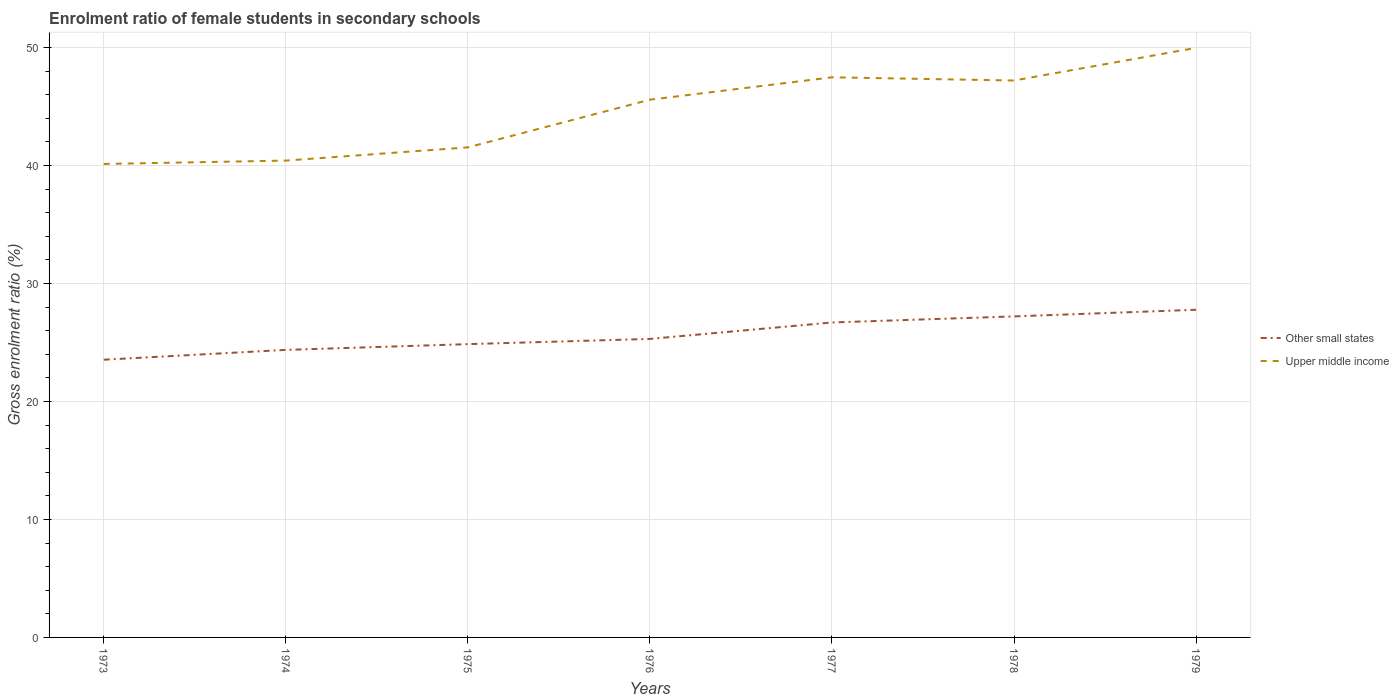Does the line corresponding to Other small states intersect with the line corresponding to Upper middle income?
Keep it short and to the point. No. Across all years, what is the maximum enrolment ratio of female students in secondary schools in Upper middle income?
Your response must be concise. 40.13. What is the total enrolment ratio of female students in secondary schools in Other small states in the graph?
Offer a very short reply. -0.49. What is the difference between the highest and the second highest enrolment ratio of female students in secondary schools in Other small states?
Ensure brevity in your answer.  4.23. Is the enrolment ratio of female students in secondary schools in Other small states strictly greater than the enrolment ratio of female students in secondary schools in Upper middle income over the years?
Keep it short and to the point. Yes. What is the difference between two consecutive major ticks on the Y-axis?
Your response must be concise. 10. Does the graph contain any zero values?
Provide a succinct answer. No. How many legend labels are there?
Your answer should be compact. 2. What is the title of the graph?
Ensure brevity in your answer.  Enrolment ratio of female students in secondary schools. Does "West Bank and Gaza" appear as one of the legend labels in the graph?
Make the answer very short. No. What is the Gross enrolment ratio (%) of Other small states in 1973?
Provide a short and direct response. 23.54. What is the Gross enrolment ratio (%) in Upper middle income in 1973?
Your answer should be very brief. 40.13. What is the Gross enrolment ratio (%) in Other small states in 1974?
Your response must be concise. 24.37. What is the Gross enrolment ratio (%) in Upper middle income in 1974?
Ensure brevity in your answer.  40.42. What is the Gross enrolment ratio (%) of Other small states in 1975?
Make the answer very short. 24.86. What is the Gross enrolment ratio (%) in Upper middle income in 1975?
Offer a terse response. 41.54. What is the Gross enrolment ratio (%) of Other small states in 1976?
Your answer should be very brief. 25.3. What is the Gross enrolment ratio (%) in Upper middle income in 1976?
Your response must be concise. 45.58. What is the Gross enrolment ratio (%) of Other small states in 1977?
Make the answer very short. 26.7. What is the Gross enrolment ratio (%) in Upper middle income in 1977?
Your answer should be very brief. 47.48. What is the Gross enrolment ratio (%) of Other small states in 1978?
Your answer should be compact. 27.21. What is the Gross enrolment ratio (%) of Upper middle income in 1978?
Make the answer very short. 47.21. What is the Gross enrolment ratio (%) of Other small states in 1979?
Give a very brief answer. 27.77. What is the Gross enrolment ratio (%) in Upper middle income in 1979?
Your answer should be compact. 49.98. Across all years, what is the maximum Gross enrolment ratio (%) in Other small states?
Keep it short and to the point. 27.77. Across all years, what is the maximum Gross enrolment ratio (%) in Upper middle income?
Make the answer very short. 49.98. Across all years, what is the minimum Gross enrolment ratio (%) in Other small states?
Your response must be concise. 23.54. Across all years, what is the minimum Gross enrolment ratio (%) in Upper middle income?
Your answer should be very brief. 40.13. What is the total Gross enrolment ratio (%) in Other small states in the graph?
Keep it short and to the point. 179.76. What is the total Gross enrolment ratio (%) in Upper middle income in the graph?
Your answer should be compact. 312.34. What is the difference between the Gross enrolment ratio (%) of Other small states in 1973 and that in 1974?
Make the answer very short. -0.83. What is the difference between the Gross enrolment ratio (%) in Upper middle income in 1973 and that in 1974?
Ensure brevity in your answer.  -0.29. What is the difference between the Gross enrolment ratio (%) of Other small states in 1973 and that in 1975?
Offer a very short reply. -1.32. What is the difference between the Gross enrolment ratio (%) in Upper middle income in 1973 and that in 1975?
Give a very brief answer. -1.41. What is the difference between the Gross enrolment ratio (%) in Other small states in 1973 and that in 1976?
Your answer should be compact. -1.76. What is the difference between the Gross enrolment ratio (%) in Upper middle income in 1973 and that in 1976?
Offer a terse response. -5.45. What is the difference between the Gross enrolment ratio (%) in Other small states in 1973 and that in 1977?
Keep it short and to the point. -3.16. What is the difference between the Gross enrolment ratio (%) of Upper middle income in 1973 and that in 1977?
Offer a terse response. -7.34. What is the difference between the Gross enrolment ratio (%) in Other small states in 1973 and that in 1978?
Keep it short and to the point. -3.67. What is the difference between the Gross enrolment ratio (%) of Upper middle income in 1973 and that in 1978?
Ensure brevity in your answer.  -7.07. What is the difference between the Gross enrolment ratio (%) of Other small states in 1973 and that in 1979?
Offer a terse response. -4.23. What is the difference between the Gross enrolment ratio (%) in Upper middle income in 1973 and that in 1979?
Your answer should be compact. -9.84. What is the difference between the Gross enrolment ratio (%) in Other small states in 1974 and that in 1975?
Provide a succinct answer. -0.49. What is the difference between the Gross enrolment ratio (%) in Upper middle income in 1974 and that in 1975?
Your response must be concise. -1.12. What is the difference between the Gross enrolment ratio (%) in Other small states in 1974 and that in 1976?
Ensure brevity in your answer.  -0.93. What is the difference between the Gross enrolment ratio (%) of Upper middle income in 1974 and that in 1976?
Make the answer very short. -5.16. What is the difference between the Gross enrolment ratio (%) in Other small states in 1974 and that in 1977?
Give a very brief answer. -2.32. What is the difference between the Gross enrolment ratio (%) of Upper middle income in 1974 and that in 1977?
Keep it short and to the point. -7.06. What is the difference between the Gross enrolment ratio (%) in Other small states in 1974 and that in 1978?
Offer a very short reply. -2.84. What is the difference between the Gross enrolment ratio (%) in Upper middle income in 1974 and that in 1978?
Your response must be concise. -6.79. What is the difference between the Gross enrolment ratio (%) of Other small states in 1974 and that in 1979?
Your answer should be compact. -3.4. What is the difference between the Gross enrolment ratio (%) in Upper middle income in 1974 and that in 1979?
Your answer should be compact. -9.56. What is the difference between the Gross enrolment ratio (%) of Other small states in 1975 and that in 1976?
Provide a short and direct response. -0.44. What is the difference between the Gross enrolment ratio (%) of Upper middle income in 1975 and that in 1976?
Your answer should be compact. -4.04. What is the difference between the Gross enrolment ratio (%) in Other small states in 1975 and that in 1977?
Your answer should be very brief. -1.84. What is the difference between the Gross enrolment ratio (%) of Upper middle income in 1975 and that in 1977?
Offer a very short reply. -5.94. What is the difference between the Gross enrolment ratio (%) of Other small states in 1975 and that in 1978?
Provide a succinct answer. -2.35. What is the difference between the Gross enrolment ratio (%) in Upper middle income in 1975 and that in 1978?
Give a very brief answer. -5.67. What is the difference between the Gross enrolment ratio (%) of Other small states in 1975 and that in 1979?
Ensure brevity in your answer.  -2.91. What is the difference between the Gross enrolment ratio (%) of Upper middle income in 1975 and that in 1979?
Make the answer very short. -8.44. What is the difference between the Gross enrolment ratio (%) in Other small states in 1976 and that in 1977?
Provide a short and direct response. -1.39. What is the difference between the Gross enrolment ratio (%) in Upper middle income in 1976 and that in 1977?
Provide a succinct answer. -1.9. What is the difference between the Gross enrolment ratio (%) of Other small states in 1976 and that in 1978?
Offer a very short reply. -1.91. What is the difference between the Gross enrolment ratio (%) in Upper middle income in 1976 and that in 1978?
Your response must be concise. -1.63. What is the difference between the Gross enrolment ratio (%) in Other small states in 1976 and that in 1979?
Provide a short and direct response. -2.47. What is the difference between the Gross enrolment ratio (%) in Upper middle income in 1976 and that in 1979?
Provide a short and direct response. -4.4. What is the difference between the Gross enrolment ratio (%) in Other small states in 1977 and that in 1978?
Your answer should be very brief. -0.52. What is the difference between the Gross enrolment ratio (%) in Upper middle income in 1977 and that in 1978?
Ensure brevity in your answer.  0.27. What is the difference between the Gross enrolment ratio (%) in Other small states in 1977 and that in 1979?
Offer a terse response. -1.08. What is the difference between the Gross enrolment ratio (%) in Upper middle income in 1977 and that in 1979?
Offer a terse response. -2.5. What is the difference between the Gross enrolment ratio (%) in Other small states in 1978 and that in 1979?
Provide a succinct answer. -0.56. What is the difference between the Gross enrolment ratio (%) of Upper middle income in 1978 and that in 1979?
Give a very brief answer. -2.77. What is the difference between the Gross enrolment ratio (%) in Other small states in 1973 and the Gross enrolment ratio (%) in Upper middle income in 1974?
Your answer should be compact. -16.88. What is the difference between the Gross enrolment ratio (%) in Other small states in 1973 and the Gross enrolment ratio (%) in Upper middle income in 1975?
Offer a very short reply. -18. What is the difference between the Gross enrolment ratio (%) of Other small states in 1973 and the Gross enrolment ratio (%) of Upper middle income in 1976?
Provide a succinct answer. -22.04. What is the difference between the Gross enrolment ratio (%) of Other small states in 1973 and the Gross enrolment ratio (%) of Upper middle income in 1977?
Offer a very short reply. -23.94. What is the difference between the Gross enrolment ratio (%) in Other small states in 1973 and the Gross enrolment ratio (%) in Upper middle income in 1978?
Ensure brevity in your answer.  -23.67. What is the difference between the Gross enrolment ratio (%) in Other small states in 1973 and the Gross enrolment ratio (%) in Upper middle income in 1979?
Ensure brevity in your answer.  -26.44. What is the difference between the Gross enrolment ratio (%) in Other small states in 1974 and the Gross enrolment ratio (%) in Upper middle income in 1975?
Offer a terse response. -17.17. What is the difference between the Gross enrolment ratio (%) of Other small states in 1974 and the Gross enrolment ratio (%) of Upper middle income in 1976?
Keep it short and to the point. -21.21. What is the difference between the Gross enrolment ratio (%) in Other small states in 1974 and the Gross enrolment ratio (%) in Upper middle income in 1977?
Your answer should be compact. -23.1. What is the difference between the Gross enrolment ratio (%) of Other small states in 1974 and the Gross enrolment ratio (%) of Upper middle income in 1978?
Make the answer very short. -22.83. What is the difference between the Gross enrolment ratio (%) of Other small states in 1974 and the Gross enrolment ratio (%) of Upper middle income in 1979?
Offer a terse response. -25.6. What is the difference between the Gross enrolment ratio (%) of Other small states in 1975 and the Gross enrolment ratio (%) of Upper middle income in 1976?
Offer a terse response. -20.72. What is the difference between the Gross enrolment ratio (%) in Other small states in 1975 and the Gross enrolment ratio (%) in Upper middle income in 1977?
Your response must be concise. -22.62. What is the difference between the Gross enrolment ratio (%) of Other small states in 1975 and the Gross enrolment ratio (%) of Upper middle income in 1978?
Ensure brevity in your answer.  -22.35. What is the difference between the Gross enrolment ratio (%) of Other small states in 1975 and the Gross enrolment ratio (%) of Upper middle income in 1979?
Provide a short and direct response. -25.12. What is the difference between the Gross enrolment ratio (%) in Other small states in 1976 and the Gross enrolment ratio (%) in Upper middle income in 1977?
Ensure brevity in your answer.  -22.18. What is the difference between the Gross enrolment ratio (%) in Other small states in 1976 and the Gross enrolment ratio (%) in Upper middle income in 1978?
Give a very brief answer. -21.9. What is the difference between the Gross enrolment ratio (%) of Other small states in 1976 and the Gross enrolment ratio (%) of Upper middle income in 1979?
Your answer should be very brief. -24.67. What is the difference between the Gross enrolment ratio (%) of Other small states in 1977 and the Gross enrolment ratio (%) of Upper middle income in 1978?
Make the answer very short. -20.51. What is the difference between the Gross enrolment ratio (%) of Other small states in 1977 and the Gross enrolment ratio (%) of Upper middle income in 1979?
Give a very brief answer. -23.28. What is the difference between the Gross enrolment ratio (%) of Other small states in 1978 and the Gross enrolment ratio (%) of Upper middle income in 1979?
Provide a succinct answer. -22.76. What is the average Gross enrolment ratio (%) in Other small states per year?
Offer a terse response. 25.68. What is the average Gross enrolment ratio (%) of Upper middle income per year?
Offer a very short reply. 44.62. In the year 1973, what is the difference between the Gross enrolment ratio (%) of Other small states and Gross enrolment ratio (%) of Upper middle income?
Give a very brief answer. -16.59. In the year 1974, what is the difference between the Gross enrolment ratio (%) of Other small states and Gross enrolment ratio (%) of Upper middle income?
Provide a succinct answer. -16.05. In the year 1975, what is the difference between the Gross enrolment ratio (%) of Other small states and Gross enrolment ratio (%) of Upper middle income?
Your answer should be very brief. -16.68. In the year 1976, what is the difference between the Gross enrolment ratio (%) of Other small states and Gross enrolment ratio (%) of Upper middle income?
Keep it short and to the point. -20.28. In the year 1977, what is the difference between the Gross enrolment ratio (%) of Other small states and Gross enrolment ratio (%) of Upper middle income?
Offer a terse response. -20.78. In the year 1978, what is the difference between the Gross enrolment ratio (%) of Other small states and Gross enrolment ratio (%) of Upper middle income?
Your answer should be very brief. -19.99. In the year 1979, what is the difference between the Gross enrolment ratio (%) in Other small states and Gross enrolment ratio (%) in Upper middle income?
Make the answer very short. -22.2. What is the ratio of the Gross enrolment ratio (%) in Other small states in 1973 to that in 1974?
Provide a short and direct response. 0.97. What is the ratio of the Gross enrolment ratio (%) of Other small states in 1973 to that in 1975?
Keep it short and to the point. 0.95. What is the ratio of the Gross enrolment ratio (%) in Upper middle income in 1973 to that in 1975?
Ensure brevity in your answer.  0.97. What is the ratio of the Gross enrolment ratio (%) in Other small states in 1973 to that in 1976?
Give a very brief answer. 0.93. What is the ratio of the Gross enrolment ratio (%) in Upper middle income in 1973 to that in 1976?
Provide a short and direct response. 0.88. What is the ratio of the Gross enrolment ratio (%) of Other small states in 1973 to that in 1977?
Your answer should be very brief. 0.88. What is the ratio of the Gross enrolment ratio (%) in Upper middle income in 1973 to that in 1977?
Ensure brevity in your answer.  0.85. What is the ratio of the Gross enrolment ratio (%) of Other small states in 1973 to that in 1978?
Make the answer very short. 0.86. What is the ratio of the Gross enrolment ratio (%) in Upper middle income in 1973 to that in 1978?
Make the answer very short. 0.85. What is the ratio of the Gross enrolment ratio (%) of Other small states in 1973 to that in 1979?
Offer a very short reply. 0.85. What is the ratio of the Gross enrolment ratio (%) in Upper middle income in 1973 to that in 1979?
Your response must be concise. 0.8. What is the ratio of the Gross enrolment ratio (%) of Other small states in 1974 to that in 1975?
Keep it short and to the point. 0.98. What is the ratio of the Gross enrolment ratio (%) in Other small states in 1974 to that in 1976?
Your answer should be very brief. 0.96. What is the ratio of the Gross enrolment ratio (%) of Upper middle income in 1974 to that in 1976?
Your response must be concise. 0.89. What is the ratio of the Gross enrolment ratio (%) in Upper middle income in 1974 to that in 1977?
Offer a terse response. 0.85. What is the ratio of the Gross enrolment ratio (%) of Other small states in 1974 to that in 1978?
Give a very brief answer. 0.9. What is the ratio of the Gross enrolment ratio (%) of Upper middle income in 1974 to that in 1978?
Provide a succinct answer. 0.86. What is the ratio of the Gross enrolment ratio (%) of Other small states in 1974 to that in 1979?
Your answer should be compact. 0.88. What is the ratio of the Gross enrolment ratio (%) in Upper middle income in 1974 to that in 1979?
Your answer should be compact. 0.81. What is the ratio of the Gross enrolment ratio (%) in Other small states in 1975 to that in 1976?
Offer a terse response. 0.98. What is the ratio of the Gross enrolment ratio (%) of Upper middle income in 1975 to that in 1976?
Offer a terse response. 0.91. What is the ratio of the Gross enrolment ratio (%) in Other small states in 1975 to that in 1977?
Provide a short and direct response. 0.93. What is the ratio of the Gross enrolment ratio (%) in Upper middle income in 1975 to that in 1977?
Provide a succinct answer. 0.87. What is the ratio of the Gross enrolment ratio (%) in Other small states in 1975 to that in 1978?
Offer a terse response. 0.91. What is the ratio of the Gross enrolment ratio (%) of Upper middle income in 1975 to that in 1978?
Your answer should be very brief. 0.88. What is the ratio of the Gross enrolment ratio (%) of Other small states in 1975 to that in 1979?
Your response must be concise. 0.9. What is the ratio of the Gross enrolment ratio (%) in Upper middle income in 1975 to that in 1979?
Keep it short and to the point. 0.83. What is the ratio of the Gross enrolment ratio (%) of Other small states in 1976 to that in 1977?
Provide a succinct answer. 0.95. What is the ratio of the Gross enrolment ratio (%) in Other small states in 1976 to that in 1978?
Provide a short and direct response. 0.93. What is the ratio of the Gross enrolment ratio (%) of Upper middle income in 1976 to that in 1978?
Make the answer very short. 0.97. What is the ratio of the Gross enrolment ratio (%) in Other small states in 1976 to that in 1979?
Offer a very short reply. 0.91. What is the ratio of the Gross enrolment ratio (%) in Upper middle income in 1976 to that in 1979?
Your answer should be very brief. 0.91. What is the ratio of the Gross enrolment ratio (%) of Other small states in 1977 to that in 1978?
Offer a very short reply. 0.98. What is the ratio of the Gross enrolment ratio (%) of Other small states in 1977 to that in 1979?
Offer a very short reply. 0.96. What is the ratio of the Gross enrolment ratio (%) of Upper middle income in 1977 to that in 1979?
Give a very brief answer. 0.95. What is the ratio of the Gross enrolment ratio (%) in Other small states in 1978 to that in 1979?
Keep it short and to the point. 0.98. What is the ratio of the Gross enrolment ratio (%) of Upper middle income in 1978 to that in 1979?
Keep it short and to the point. 0.94. What is the difference between the highest and the second highest Gross enrolment ratio (%) in Other small states?
Provide a short and direct response. 0.56. What is the difference between the highest and the second highest Gross enrolment ratio (%) in Upper middle income?
Give a very brief answer. 2.5. What is the difference between the highest and the lowest Gross enrolment ratio (%) in Other small states?
Give a very brief answer. 4.23. What is the difference between the highest and the lowest Gross enrolment ratio (%) in Upper middle income?
Give a very brief answer. 9.84. 